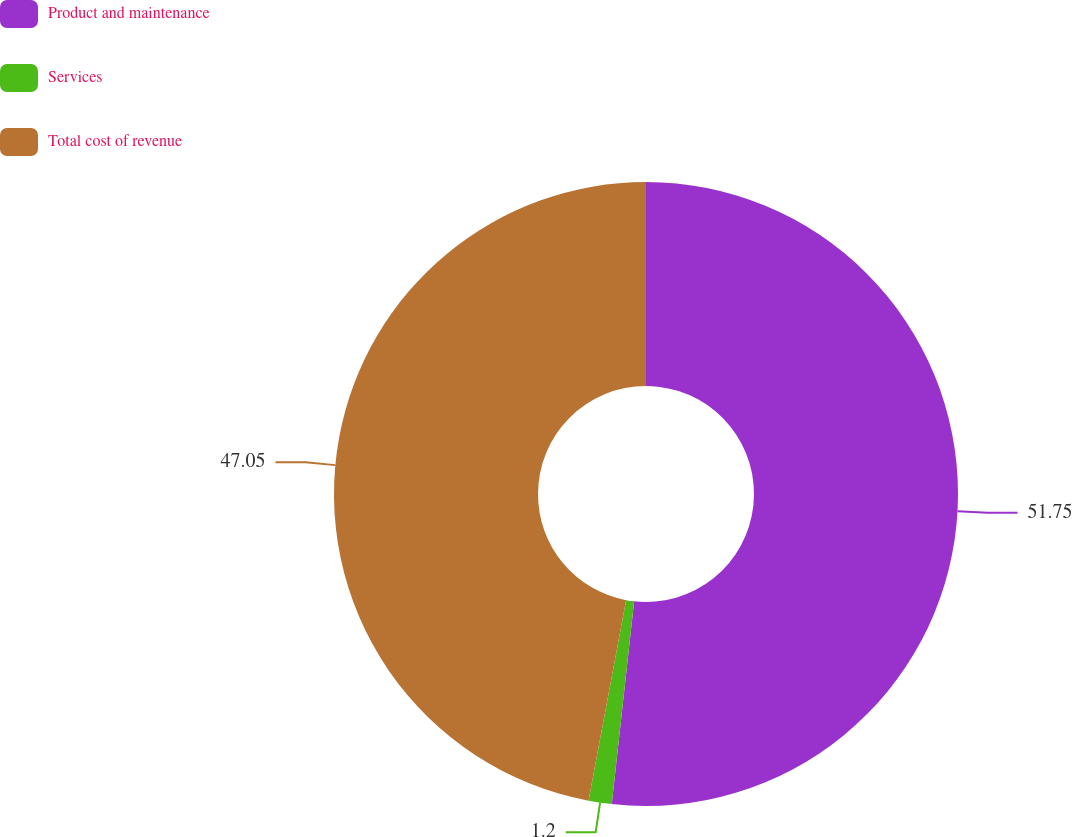<chart> <loc_0><loc_0><loc_500><loc_500><pie_chart><fcel>Product and maintenance<fcel>Services<fcel>Total cost of revenue<nl><fcel>51.75%<fcel>1.2%<fcel>47.05%<nl></chart> 